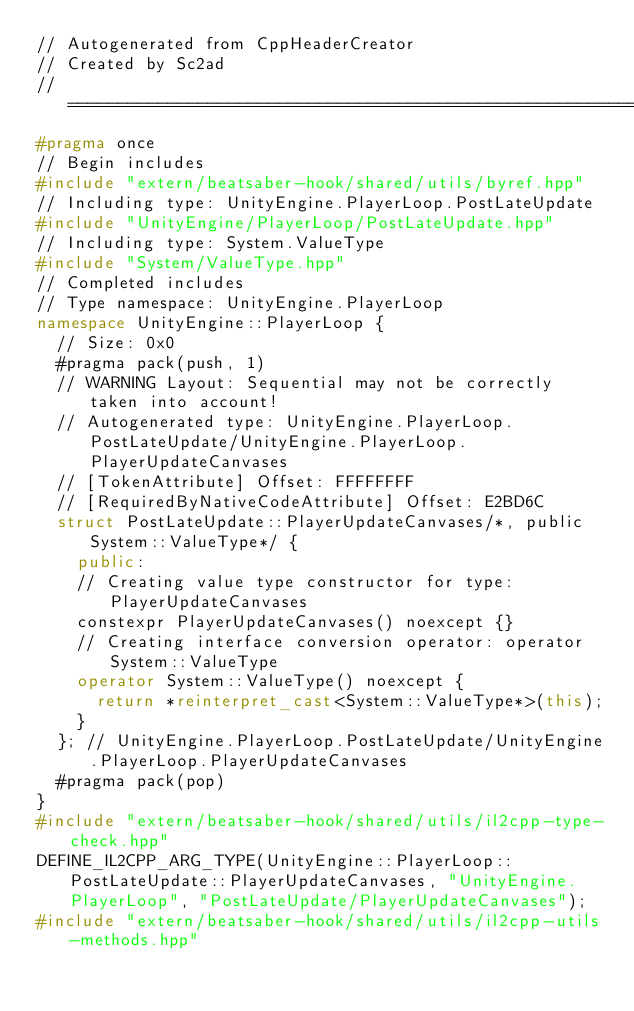<code> <loc_0><loc_0><loc_500><loc_500><_C++_>// Autogenerated from CppHeaderCreator
// Created by Sc2ad
// =========================================================================
#pragma once
// Begin includes
#include "extern/beatsaber-hook/shared/utils/byref.hpp"
// Including type: UnityEngine.PlayerLoop.PostLateUpdate
#include "UnityEngine/PlayerLoop/PostLateUpdate.hpp"
// Including type: System.ValueType
#include "System/ValueType.hpp"
// Completed includes
// Type namespace: UnityEngine.PlayerLoop
namespace UnityEngine::PlayerLoop {
  // Size: 0x0
  #pragma pack(push, 1)
  // WARNING Layout: Sequential may not be correctly taken into account!
  // Autogenerated type: UnityEngine.PlayerLoop.PostLateUpdate/UnityEngine.PlayerLoop.PlayerUpdateCanvases
  // [TokenAttribute] Offset: FFFFFFFF
  // [RequiredByNativeCodeAttribute] Offset: E2BD6C
  struct PostLateUpdate::PlayerUpdateCanvases/*, public System::ValueType*/ {
    public:
    // Creating value type constructor for type: PlayerUpdateCanvases
    constexpr PlayerUpdateCanvases() noexcept {}
    // Creating interface conversion operator: operator System::ValueType
    operator System::ValueType() noexcept {
      return *reinterpret_cast<System::ValueType*>(this);
    }
  }; // UnityEngine.PlayerLoop.PostLateUpdate/UnityEngine.PlayerLoop.PlayerUpdateCanvases
  #pragma pack(pop)
}
#include "extern/beatsaber-hook/shared/utils/il2cpp-type-check.hpp"
DEFINE_IL2CPP_ARG_TYPE(UnityEngine::PlayerLoop::PostLateUpdate::PlayerUpdateCanvases, "UnityEngine.PlayerLoop", "PostLateUpdate/PlayerUpdateCanvases");
#include "extern/beatsaber-hook/shared/utils/il2cpp-utils-methods.hpp"
</code> 